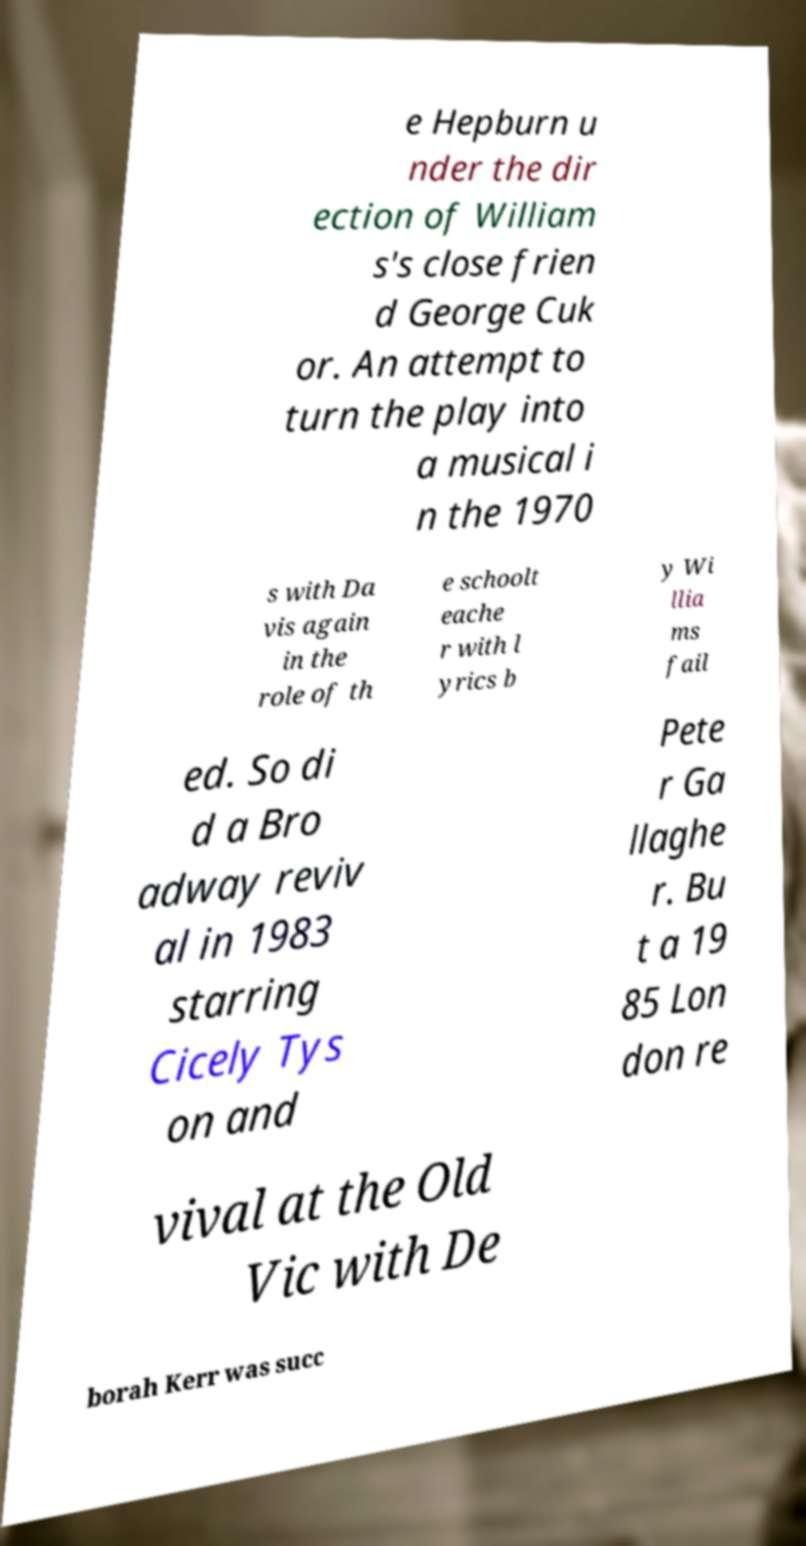There's text embedded in this image that I need extracted. Can you transcribe it verbatim? e Hepburn u nder the dir ection of William s's close frien d George Cuk or. An attempt to turn the play into a musical i n the 1970 s with Da vis again in the role of th e schoolt eache r with l yrics b y Wi llia ms fail ed. So di d a Bro adway reviv al in 1983 starring Cicely Tys on and Pete r Ga llaghe r. Bu t a 19 85 Lon don re vival at the Old Vic with De borah Kerr was succ 